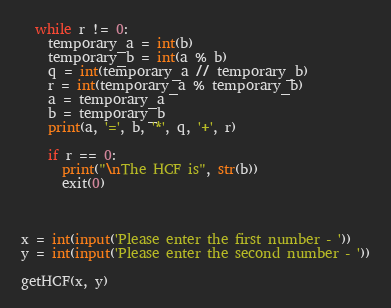Convert code to text. <code><loc_0><loc_0><loc_500><loc_500><_Python_>
  while r != 0:
    temporary_a = int(b)
    temporary_b = int(a % b)
    q = int(temporary_a // temporary_b)
    r = int(temporary_a % temporary_b)
    a = temporary_a
    b = temporary_b
    print(a, '=', b, '*', q, '+', r)
    
    if r == 0:
      print("\nThe HCF is", str(b))
      exit(0)

    
  
x = int(input('Please enter the first number - '))
y = int(input('Please enter the second number - '))

getHCF(x, y)</code> 